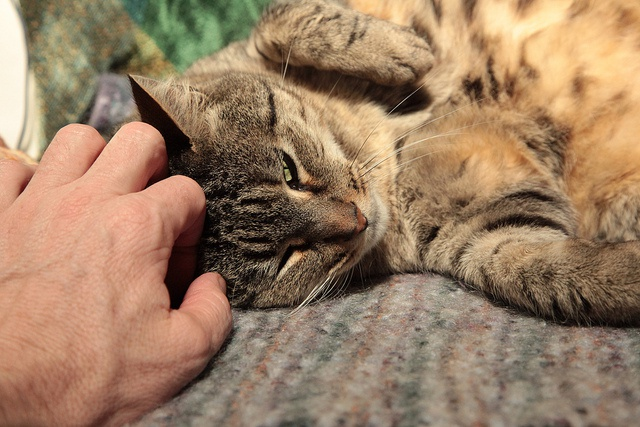Describe the objects in this image and their specific colors. I can see cat in ivory, tan, black, and gray tones and people in ivory, tan, brown, and salmon tones in this image. 